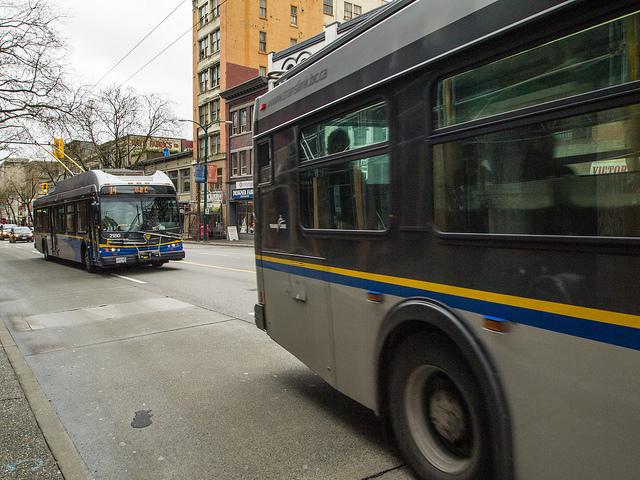How many buses are there?
Be succinct. 2. Are the buses the same color?
Concise answer only. Yes. What design is on the bus?
Quick response, please. Stripes. Do the trees have foliage?
Answer briefly. No. 